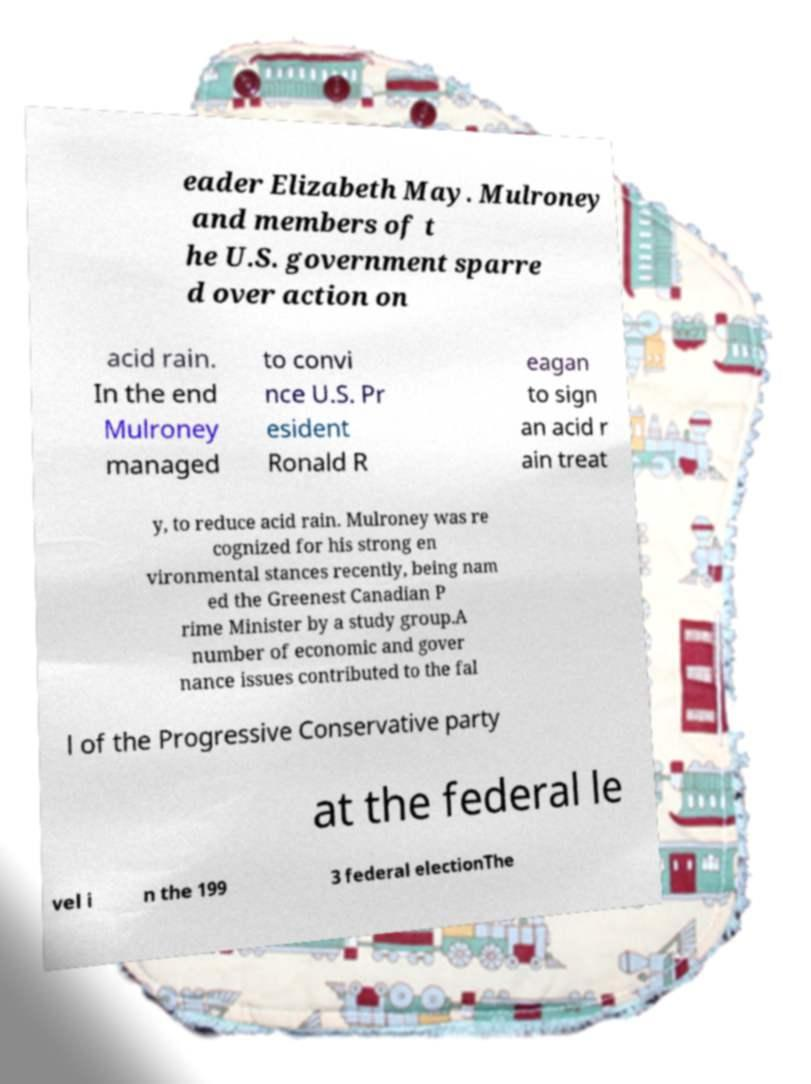There's text embedded in this image that I need extracted. Can you transcribe it verbatim? eader Elizabeth May. Mulroney and members of t he U.S. government sparre d over action on acid rain. In the end Mulroney managed to convi nce U.S. Pr esident Ronald R eagan to sign an acid r ain treat y, to reduce acid rain. Mulroney was re cognized for his strong en vironmental stances recently, being nam ed the Greenest Canadian P rime Minister by a study group.A number of economic and gover nance issues contributed to the fal l of the Progressive Conservative party at the federal le vel i n the 199 3 federal electionThe 